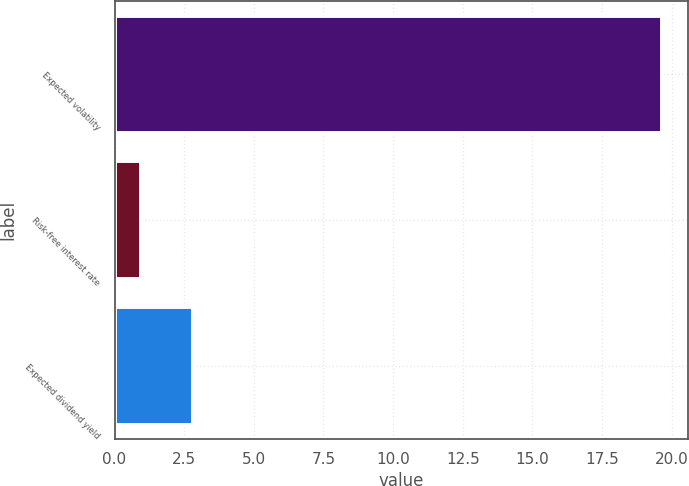Convert chart to OTSL. <chart><loc_0><loc_0><loc_500><loc_500><bar_chart><fcel>Expected volatility<fcel>Risk-free interest rate<fcel>Expected dividend yield<nl><fcel>19.6<fcel>0.9<fcel>2.77<nl></chart> 